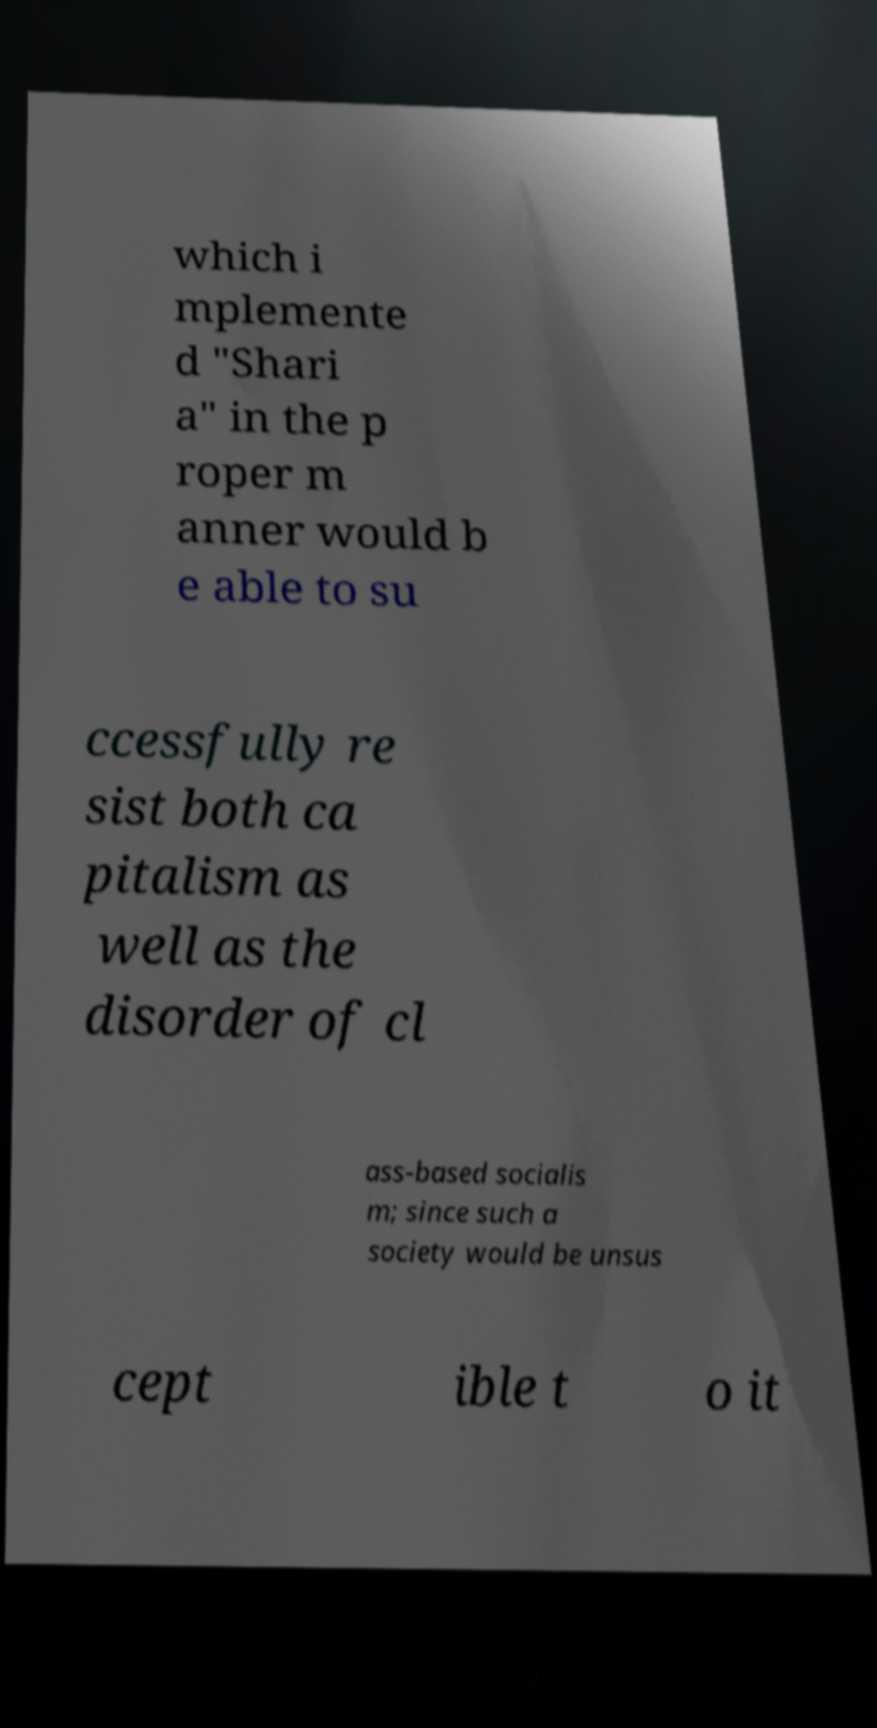Please identify and transcribe the text found in this image. which i mplemente d "Shari a" in the p roper m anner would b e able to su ccessfully re sist both ca pitalism as well as the disorder of cl ass-based socialis m; since such a society would be unsus cept ible t o it 